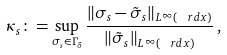Convert formula to latex. <formula><loc_0><loc_0><loc_500><loc_500>\kappa _ { s } \colon = \sup _ { \sigma _ { s } \in \Gamma _ { \delta } } \frac { \| \sigma _ { s } - \tilde { \sigma } _ { s } \| _ { L ^ { \infty } ( \ r d x ) } } { \| \tilde { \sigma } _ { s } \| _ { L ^ { \infty } ( \ r d x ) } } \, ,</formula> 